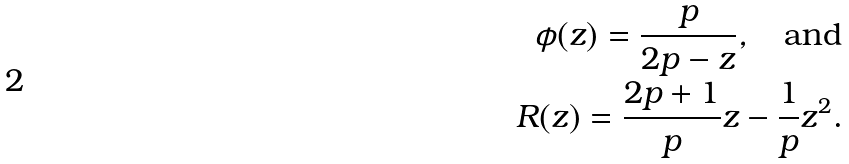<formula> <loc_0><loc_0><loc_500><loc_500>\phi ( z ) = \frac { p } { 2 p - z } , \quad \text {and} \\ R ( z ) = \frac { 2 p + 1 } p z - \frac { 1 } { p } z ^ { 2 } .</formula> 